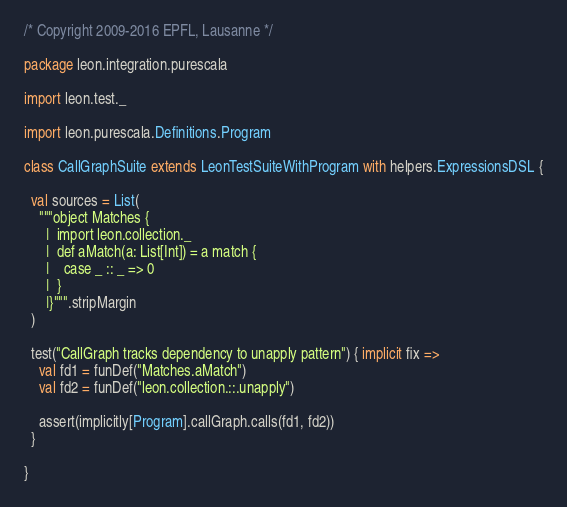Convert code to text. <code><loc_0><loc_0><loc_500><loc_500><_Scala_>/* Copyright 2009-2016 EPFL, Lausanne */

package leon.integration.purescala

import leon.test._

import leon.purescala.Definitions.Program

class CallGraphSuite extends LeonTestSuiteWithProgram with helpers.ExpressionsDSL {

  val sources = List(
    """object Matches {
      |  import leon.collection._
      |  def aMatch(a: List[Int]) = a match {
      |    case _ :: _ => 0
      |  }
      |}""".stripMargin
  )

  test("CallGraph tracks dependency to unapply pattern") { implicit fix =>
    val fd1 = funDef("Matches.aMatch")
    val fd2 = funDef("leon.collection.::.unapply")

    assert(implicitly[Program].callGraph.calls(fd1, fd2))
  }

}
</code> 